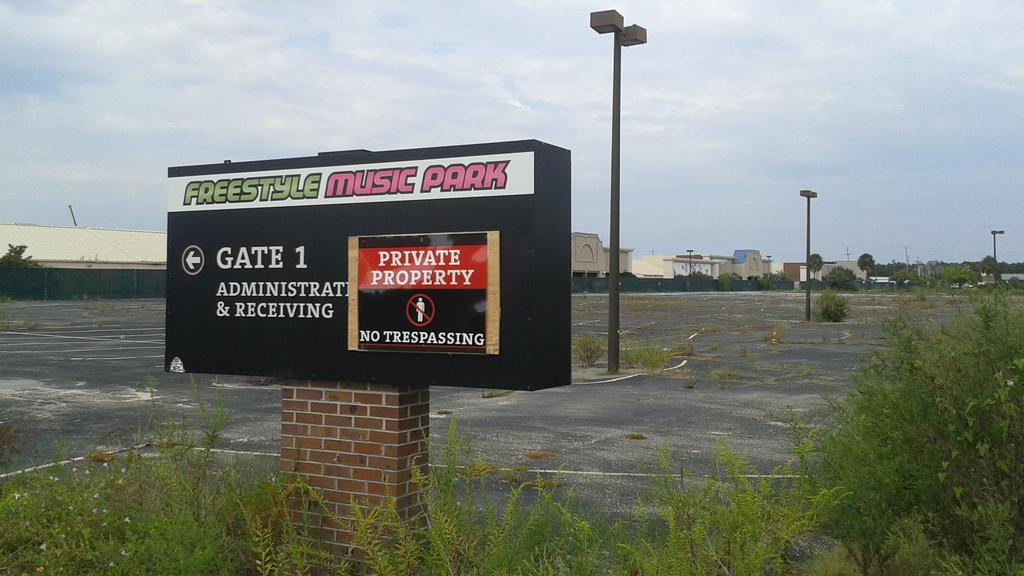Provide a one-sentence caption for the provided image. An empty parking lot with overgrown grass at gate 1 for the Freestyle Music Park is private property. 